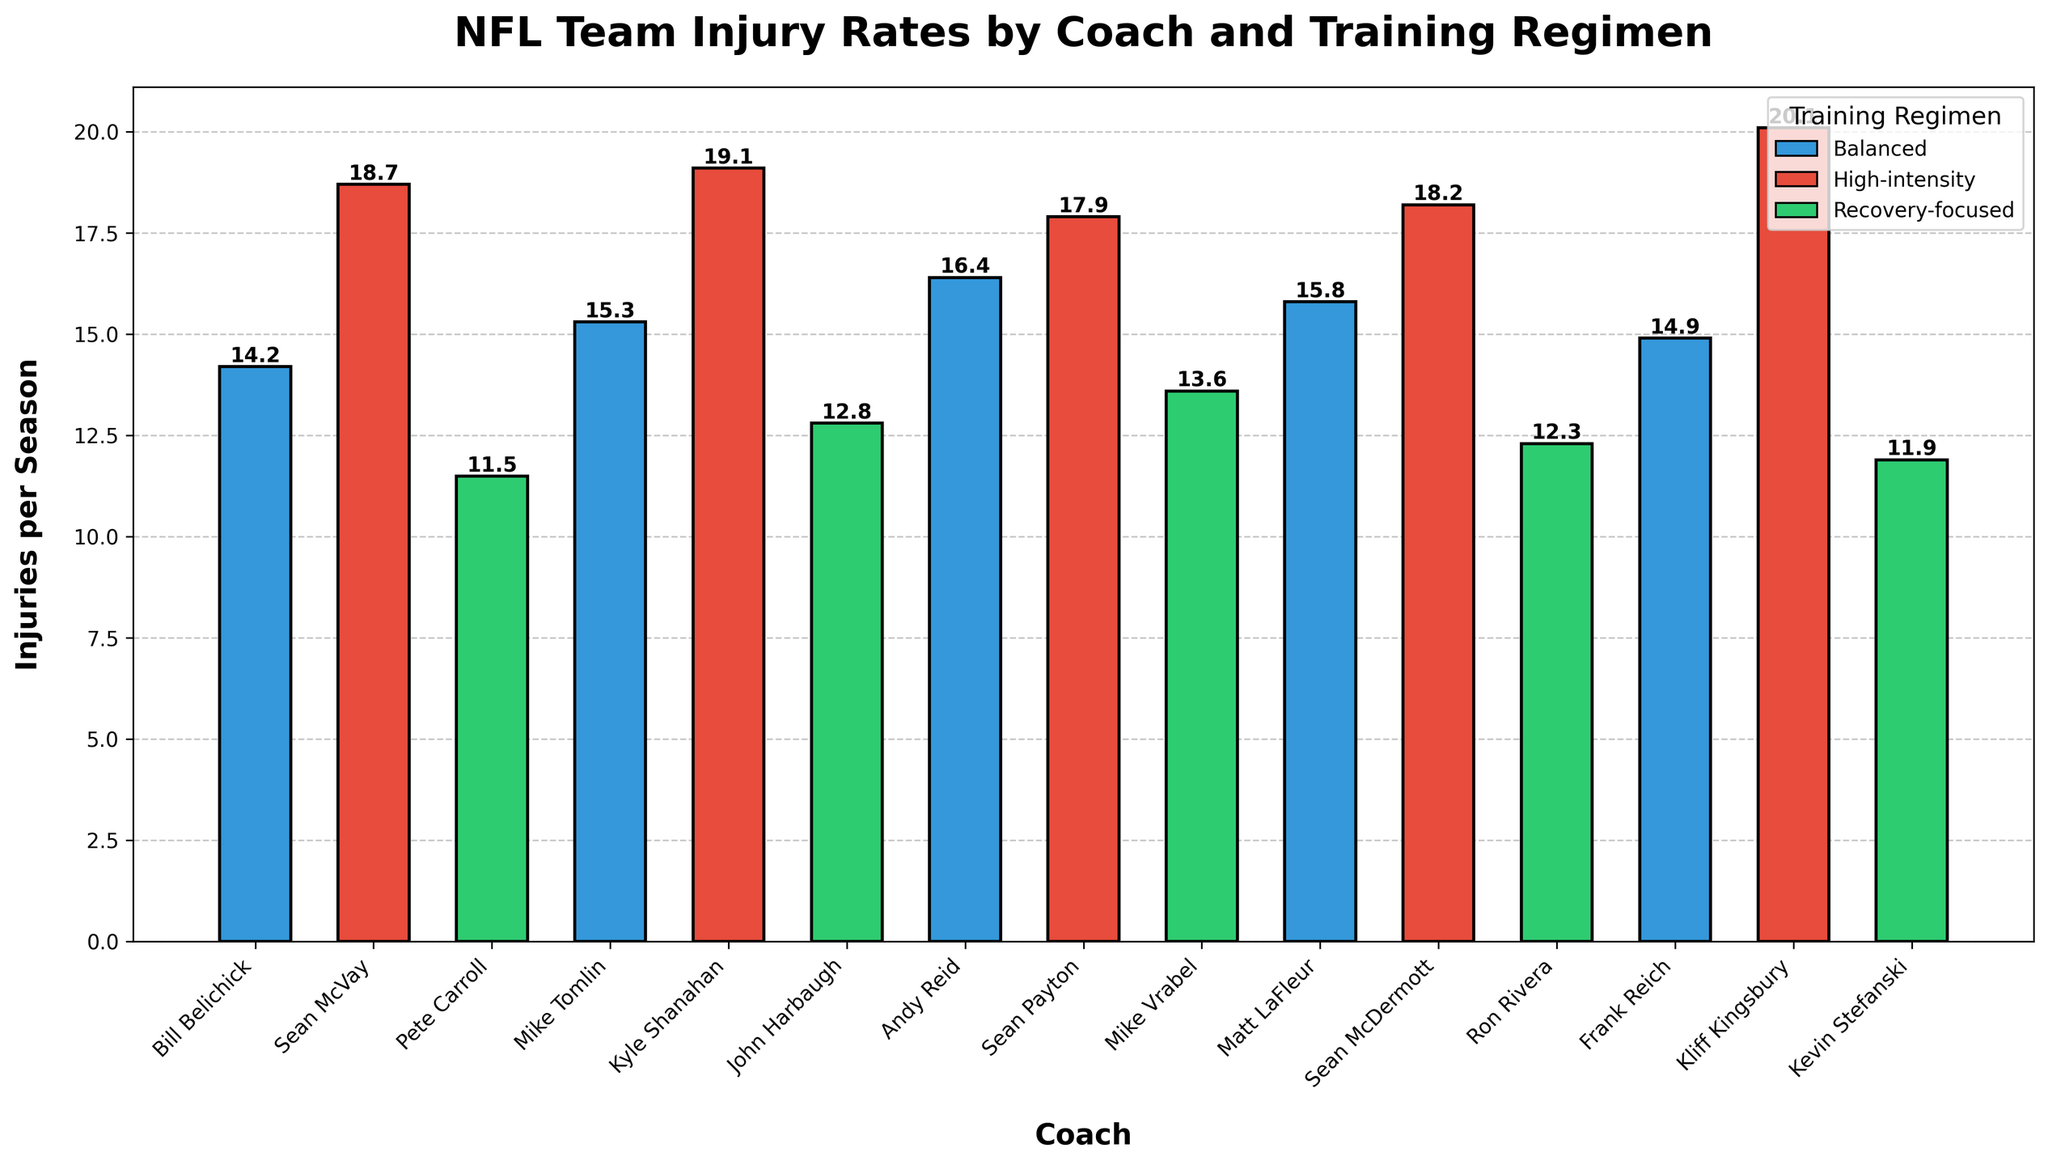What is the average number of injuries per season for teams with high-intensity training regimens? Sum the injuries for the high-intensity regimen teams: 18.7 (Sean McVay) + 19.1 (Kyle Shanahan) + 17.9 (Sean Payton) + 18.2 (Sean McDermott) + 20.1 (Kliff Kingsbury) = 94. Then, divide by the number of high-intensity teams, which is 5: 94 / 5 = 18.8
Answer: 18.8 Which coach has the lowest number of injuries per season, and what is that number? Look for the shortest bar and identify the corresponding coach and the value. Pete Carroll has the shortest bar with 11.5 injuries per season
Answer: Pete Carroll, 11.5 How do the injuries per season for recovery-focused regimen teams compare to those for balanced regimen teams in terms of average? Calculate the average for recovery-focused regimen teams: (11.5 + 12.8 + 13.6 + 12.3 + 11.9) / 5 = 12.42. Do the same for balanced regimen teams: (14.2 + 15.3 + 16.4 + 15.8 + 14.9) / 5 = 15.32. Compare the two averages: 12.42 < 15.32
Answer: Recovery-focused teams have a lower average of 12.42 compared to the balanced teams' 15.32 Which team has the highest injury rate under a balanced training regimen? Identify the tallest bar among the balanced regimen teams. Andy Reid (Kansas City Chiefs) has the highest value with 16.4 injuries per season
Answer: Andy Reid (Kansas City Chiefs), 16.4 What is the total number of injuries reported for all teams under recovery-focused training regimens? Sum the injuries for all recovery-focused regimen teams: 11.5 (Pete Carroll) + 12.8 (John Harbaugh) + 13.6 (Mike Vrabel) + 12.3 (Ron Rivera) + 11.9 (Kevin Stefanski) = 62.1
Answer: 62.1 By how much does Kliff Kingsbury's injury rate exceed Pete Carroll's injury rate? Subtract Pete Carroll's injury rate from Kliff Kingsbury's: 20.1 (Kliff Kingsbury) - 11.5 (Pete Carroll) = 8.6
Answer: 8.6 What training regimen color represents the coaches with the least and most average injuries per season, respectively? Identify the regimen with the least average injuries (Recovery-focused, green) and the regimen with the most average injuries (High-intensity, red). Recovery: 12.42, High-intensity: 18.8
Answer: Green for least, red for most Is there a significant visual difference in injury rates between recovery-focused and high-intensity regimen teams? Comparatively, high-intensity regimen bars (red) are generally taller than recovery-focused regimen bars (green), indicating higher injury rates visually.
Answer: Yes, high-intensity bars are noticeably taller 